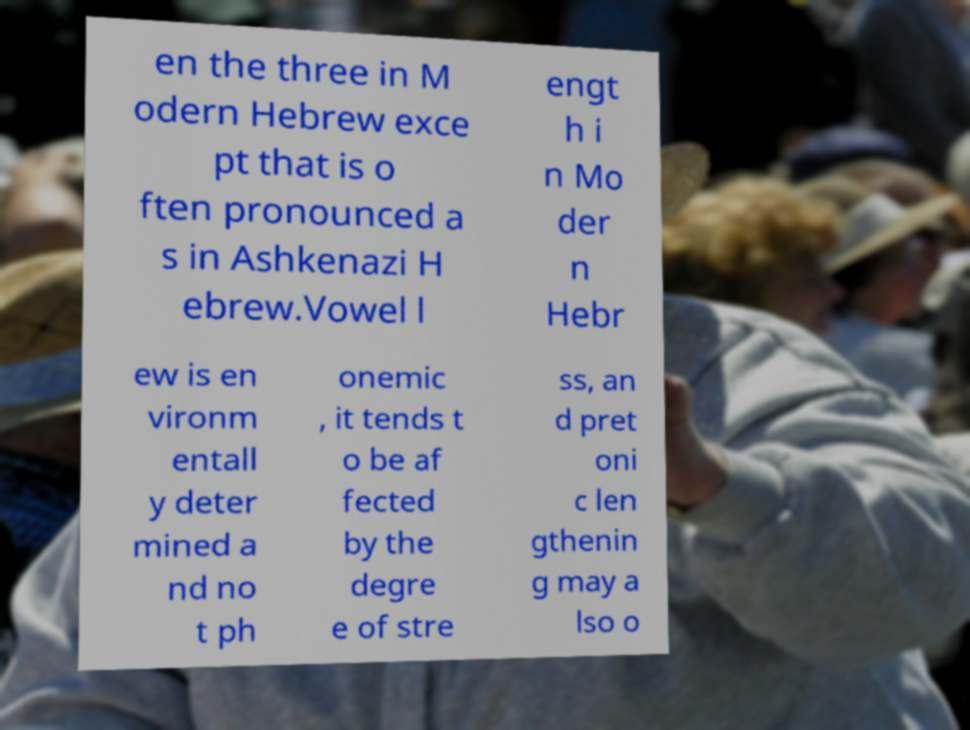For documentation purposes, I need the text within this image transcribed. Could you provide that? en the three in M odern Hebrew exce pt that is o ften pronounced a s in Ashkenazi H ebrew.Vowel l engt h i n Mo der n Hebr ew is en vironm entall y deter mined a nd no t ph onemic , it tends t o be af fected by the degre e of stre ss, an d pret oni c len gthenin g may a lso o 